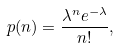Convert formula to latex. <formula><loc_0><loc_0><loc_500><loc_500>p ( n ) = \frac { \lambda ^ { n } e ^ { - \lambda } } { n ! } ,</formula> 